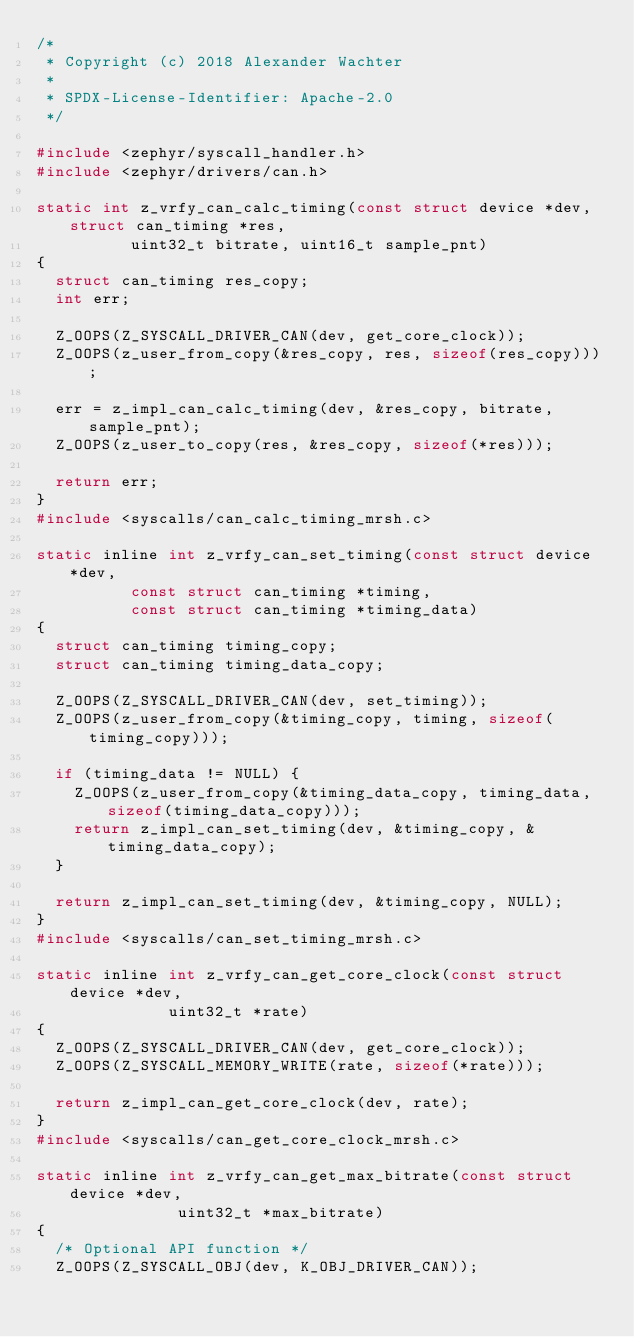<code> <loc_0><loc_0><loc_500><loc_500><_C_>/*
 * Copyright (c) 2018 Alexander Wachter
 *
 * SPDX-License-Identifier: Apache-2.0
 */

#include <zephyr/syscall_handler.h>
#include <zephyr/drivers/can.h>

static int z_vrfy_can_calc_timing(const struct device *dev, struct can_timing *res,
				  uint32_t bitrate, uint16_t sample_pnt)
{
	struct can_timing res_copy;
	int err;

	Z_OOPS(Z_SYSCALL_DRIVER_CAN(dev, get_core_clock));
	Z_OOPS(z_user_from_copy(&res_copy, res, sizeof(res_copy)));

	err = z_impl_can_calc_timing(dev, &res_copy, bitrate, sample_pnt);
	Z_OOPS(z_user_to_copy(res, &res_copy, sizeof(*res)));

	return err;
}
#include <syscalls/can_calc_timing_mrsh.c>

static inline int z_vrfy_can_set_timing(const struct device *dev,
					const struct can_timing *timing,
					const struct can_timing *timing_data)
{
	struct can_timing timing_copy;
	struct can_timing timing_data_copy;

	Z_OOPS(Z_SYSCALL_DRIVER_CAN(dev, set_timing));
	Z_OOPS(z_user_from_copy(&timing_copy, timing, sizeof(timing_copy)));

	if (timing_data != NULL) {
		Z_OOPS(z_user_from_copy(&timing_data_copy, timing_data, sizeof(timing_data_copy)));
		return z_impl_can_set_timing(dev, &timing_copy, &timing_data_copy);
	}

	return z_impl_can_set_timing(dev, &timing_copy, NULL);
}
#include <syscalls/can_set_timing_mrsh.c>

static inline int z_vrfy_can_get_core_clock(const struct device *dev,
					    uint32_t *rate)
{
	Z_OOPS(Z_SYSCALL_DRIVER_CAN(dev, get_core_clock));
	Z_OOPS(Z_SYSCALL_MEMORY_WRITE(rate, sizeof(*rate)));

	return z_impl_can_get_core_clock(dev, rate);
}
#include <syscalls/can_get_core_clock_mrsh.c>

static inline int z_vrfy_can_get_max_bitrate(const struct device *dev,
					     uint32_t *max_bitrate)
{
	/* Optional API function */
	Z_OOPS(Z_SYSCALL_OBJ(dev, K_OBJ_DRIVER_CAN));</code> 